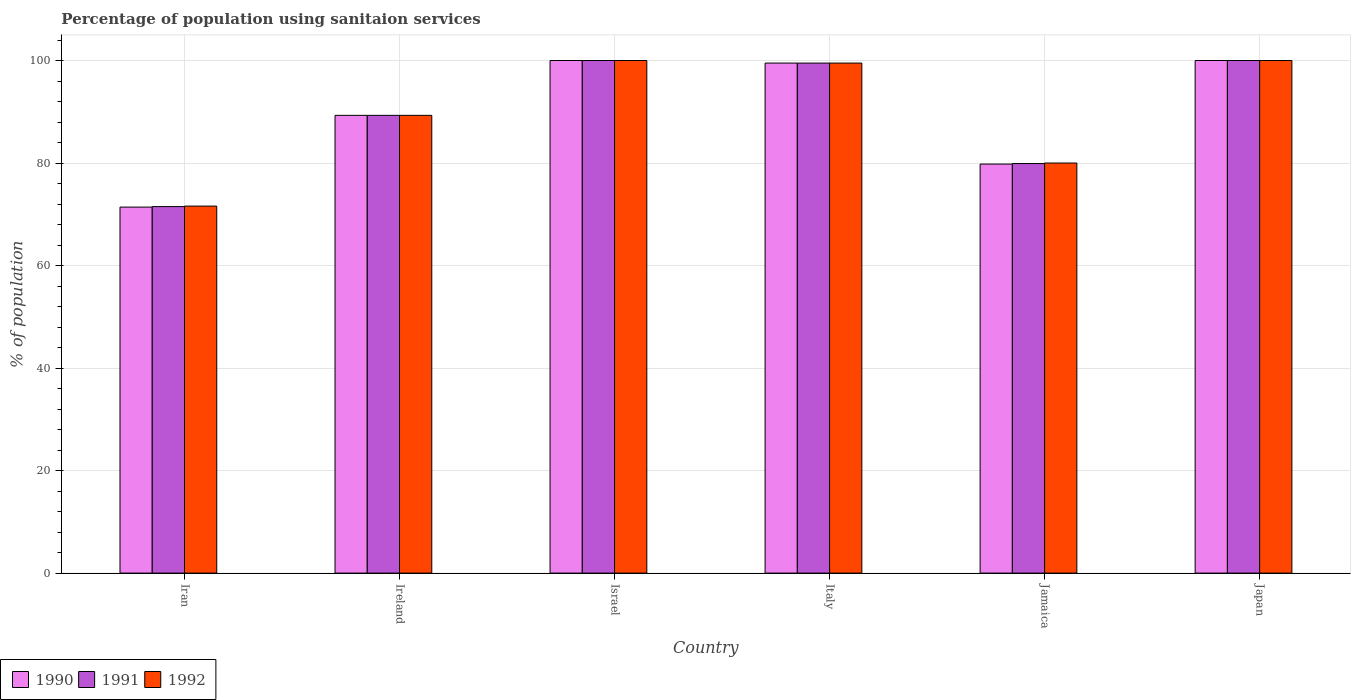How many different coloured bars are there?
Offer a terse response. 3. Are the number of bars per tick equal to the number of legend labels?
Offer a terse response. Yes. Are the number of bars on each tick of the X-axis equal?
Keep it short and to the point. Yes. How many bars are there on the 4th tick from the right?
Make the answer very short. 3. What is the percentage of population using sanitaion services in 1990 in Israel?
Make the answer very short. 100. Across all countries, what is the maximum percentage of population using sanitaion services in 1992?
Provide a short and direct response. 100. Across all countries, what is the minimum percentage of population using sanitaion services in 1991?
Give a very brief answer. 71.5. In which country was the percentage of population using sanitaion services in 1990 maximum?
Give a very brief answer. Israel. In which country was the percentage of population using sanitaion services in 1990 minimum?
Your answer should be very brief. Iran. What is the total percentage of population using sanitaion services in 1990 in the graph?
Provide a short and direct response. 540. What is the difference between the percentage of population using sanitaion services in 1991 in Iran and that in Israel?
Provide a succinct answer. -28.5. What is the difference between the percentage of population using sanitaion services in 1990 in Iran and the percentage of population using sanitaion services in 1991 in Japan?
Make the answer very short. -28.6. What is the average percentage of population using sanitaion services in 1992 per country?
Offer a very short reply. 90.07. What is the difference between the percentage of population using sanitaion services of/in 1991 and percentage of population using sanitaion services of/in 1990 in Ireland?
Your response must be concise. 0. In how many countries, is the percentage of population using sanitaion services in 1990 greater than 4 %?
Your answer should be compact. 6. What is the ratio of the percentage of population using sanitaion services in 1991 in Ireland to that in Italy?
Keep it short and to the point. 0.9. What is the difference between the highest and the lowest percentage of population using sanitaion services in 1990?
Ensure brevity in your answer.  28.6. In how many countries, is the percentage of population using sanitaion services in 1991 greater than the average percentage of population using sanitaion services in 1991 taken over all countries?
Provide a short and direct response. 3. What does the 1st bar from the left in Japan represents?
Make the answer very short. 1990. Is it the case that in every country, the sum of the percentage of population using sanitaion services in 1991 and percentage of population using sanitaion services in 1990 is greater than the percentage of population using sanitaion services in 1992?
Ensure brevity in your answer.  Yes. How many bars are there?
Your answer should be very brief. 18. Are all the bars in the graph horizontal?
Your answer should be very brief. No. How many countries are there in the graph?
Ensure brevity in your answer.  6. Does the graph contain any zero values?
Ensure brevity in your answer.  No. Does the graph contain grids?
Ensure brevity in your answer.  Yes. How are the legend labels stacked?
Ensure brevity in your answer.  Horizontal. What is the title of the graph?
Ensure brevity in your answer.  Percentage of population using sanitaion services. What is the label or title of the X-axis?
Offer a very short reply. Country. What is the label or title of the Y-axis?
Your answer should be very brief. % of population. What is the % of population in 1990 in Iran?
Give a very brief answer. 71.4. What is the % of population of 1991 in Iran?
Provide a short and direct response. 71.5. What is the % of population of 1992 in Iran?
Your response must be concise. 71.6. What is the % of population in 1990 in Ireland?
Your response must be concise. 89.3. What is the % of population of 1991 in Ireland?
Keep it short and to the point. 89.3. What is the % of population of 1992 in Ireland?
Make the answer very short. 89.3. What is the % of population of 1990 in Israel?
Your answer should be compact. 100. What is the % of population of 1991 in Israel?
Provide a short and direct response. 100. What is the % of population of 1990 in Italy?
Provide a short and direct response. 99.5. What is the % of population in 1991 in Italy?
Your answer should be very brief. 99.5. What is the % of population of 1992 in Italy?
Offer a very short reply. 99.5. What is the % of population in 1990 in Jamaica?
Your answer should be compact. 79.8. What is the % of population of 1991 in Jamaica?
Your response must be concise. 79.9. What is the % of population of 1992 in Japan?
Your answer should be very brief. 100. Across all countries, what is the maximum % of population in 1991?
Your answer should be very brief. 100. Across all countries, what is the maximum % of population of 1992?
Your answer should be very brief. 100. Across all countries, what is the minimum % of population in 1990?
Provide a succinct answer. 71.4. Across all countries, what is the minimum % of population in 1991?
Make the answer very short. 71.5. Across all countries, what is the minimum % of population in 1992?
Provide a short and direct response. 71.6. What is the total % of population in 1990 in the graph?
Keep it short and to the point. 540. What is the total % of population of 1991 in the graph?
Keep it short and to the point. 540.2. What is the total % of population of 1992 in the graph?
Provide a succinct answer. 540.4. What is the difference between the % of population in 1990 in Iran and that in Ireland?
Keep it short and to the point. -17.9. What is the difference between the % of population in 1991 in Iran and that in Ireland?
Keep it short and to the point. -17.8. What is the difference between the % of population of 1992 in Iran and that in Ireland?
Provide a short and direct response. -17.7. What is the difference between the % of population of 1990 in Iran and that in Israel?
Offer a terse response. -28.6. What is the difference between the % of population of 1991 in Iran and that in Israel?
Your answer should be compact. -28.5. What is the difference between the % of population in 1992 in Iran and that in Israel?
Provide a short and direct response. -28.4. What is the difference between the % of population in 1990 in Iran and that in Italy?
Provide a succinct answer. -28.1. What is the difference between the % of population of 1991 in Iran and that in Italy?
Your answer should be compact. -28. What is the difference between the % of population of 1992 in Iran and that in Italy?
Provide a short and direct response. -27.9. What is the difference between the % of population in 1992 in Iran and that in Jamaica?
Offer a terse response. -8.4. What is the difference between the % of population of 1990 in Iran and that in Japan?
Keep it short and to the point. -28.6. What is the difference between the % of population in 1991 in Iran and that in Japan?
Your answer should be very brief. -28.5. What is the difference between the % of population in 1992 in Iran and that in Japan?
Your answer should be compact. -28.4. What is the difference between the % of population of 1992 in Ireland and that in Israel?
Give a very brief answer. -10.7. What is the difference between the % of population of 1992 in Ireland and that in Jamaica?
Offer a terse response. 9.3. What is the difference between the % of population of 1990 in Ireland and that in Japan?
Provide a succinct answer. -10.7. What is the difference between the % of population of 1992 in Ireland and that in Japan?
Your answer should be compact. -10.7. What is the difference between the % of population in 1991 in Israel and that in Italy?
Your response must be concise. 0.5. What is the difference between the % of population in 1990 in Israel and that in Jamaica?
Provide a short and direct response. 20.2. What is the difference between the % of population in 1991 in Israel and that in Jamaica?
Offer a terse response. 20.1. What is the difference between the % of population of 1992 in Israel and that in Jamaica?
Give a very brief answer. 20. What is the difference between the % of population in 1990 in Israel and that in Japan?
Keep it short and to the point. 0. What is the difference between the % of population of 1990 in Italy and that in Jamaica?
Ensure brevity in your answer.  19.7. What is the difference between the % of population in 1991 in Italy and that in Jamaica?
Your answer should be compact. 19.6. What is the difference between the % of population in 1991 in Italy and that in Japan?
Your answer should be very brief. -0.5. What is the difference between the % of population of 1990 in Jamaica and that in Japan?
Your answer should be compact. -20.2. What is the difference between the % of population in 1991 in Jamaica and that in Japan?
Make the answer very short. -20.1. What is the difference between the % of population in 1992 in Jamaica and that in Japan?
Provide a short and direct response. -20. What is the difference between the % of population in 1990 in Iran and the % of population in 1991 in Ireland?
Offer a terse response. -17.9. What is the difference between the % of population of 1990 in Iran and the % of population of 1992 in Ireland?
Offer a very short reply. -17.9. What is the difference between the % of population of 1991 in Iran and the % of population of 1992 in Ireland?
Your answer should be compact. -17.8. What is the difference between the % of population in 1990 in Iran and the % of population in 1991 in Israel?
Offer a very short reply. -28.6. What is the difference between the % of population in 1990 in Iran and the % of population in 1992 in Israel?
Your answer should be compact. -28.6. What is the difference between the % of population of 1991 in Iran and the % of population of 1992 in Israel?
Provide a short and direct response. -28.5. What is the difference between the % of population of 1990 in Iran and the % of population of 1991 in Italy?
Your answer should be very brief. -28.1. What is the difference between the % of population in 1990 in Iran and the % of population in 1992 in Italy?
Offer a terse response. -28.1. What is the difference between the % of population in 1990 in Iran and the % of population in 1992 in Jamaica?
Your answer should be very brief. -8.6. What is the difference between the % of population in 1991 in Iran and the % of population in 1992 in Jamaica?
Give a very brief answer. -8.5. What is the difference between the % of population of 1990 in Iran and the % of population of 1991 in Japan?
Make the answer very short. -28.6. What is the difference between the % of population of 1990 in Iran and the % of population of 1992 in Japan?
Make the answer very short. -28.6. What is the difference between the % of population in 1991 in Iran and the % of population in 1992 in Japan?
Provide a succinct answer. -28.5. What is the difference between the % of population in 1990 in Ireland and the % of population in 1991 in Israel?
Offer a terse response. -10.7. What is the difference between the % of population of 1991 in Ireland and the % of population of 1992 in Israel?
Provide a short and direct response. -10.7. What is the difference between the % of population in 1990 in Ireland and the % of population in 1991 in Italy?
Offer a terse response. -10.2. What is the difference between the % of population of 1990 in Ireland and the % of population of 1992 in Italy?
Your answer should be very brief. -10.2. What is the difference between the % of population of 1990 in Ireland and the % of population of 1991 in Jamaica?
Ensure brevity in your answer.  9.4. What is the difference between the % of population of 1991 in Ireland and the % of population of 1992 in Jamaica?
Offer a terse response. 9.3. What is the difference between the % of population of 1990 in Ireland and the % of population of 1991 in Japan?
Your answer should be compact. -10.7. What is the difference between the % of population of 1990 in Ireland and the % of population of 1992 in Japan?
Your response must be concise. -10.7. What is the difference between the % of population in 1991 in Ireland and the % of population in 1992 in Japan?
Your response must be concise. -10.7. What is the difference between the % of population of 1991 in Israel and the % of population of 1992 in Italy?
Give a very brief answer. 0.5. What is the difference between the % of population in 1990 in Israel and the % of population in 1991 in Jamaica?
Make the answer very short. 20.1. What is the difference between the % of population of 1991 in Israel and the % of population of 1992 in Jamaica?
Offer a terse response. 20. What is the difference between the % of population of 1990 in Italy and the % of population of 1991 in Jamaica?
Your answer should be compact. 19.6. What is the difference between the % of population of 1990 in Italy and the % of population of 1992 in Jamaica?
Offer a terse response. 19.5. What is the difference between the % of population of 1991 in Italy and the % of population of 1992 in Jamaica?
Keep it short and to the point. 19.5. What is the difference between the % of population in 1990 in Italy and the % of population in 1992 in Japan?
Your answer should be compact. -0.5. What is the difference between the % of population of 1990 in Jamaica and the % of population of 1991 in Japan?
Your answer should be compact. -20.2. What is the difference between the % of population of 1990 in Jamaica and the % of population of 1992 in Japan?
Your response must be concise. -20.2. What is the difference between the % of population in 1991 in Jamaica and the % of population in 1992 in Japan?
Make the answer very short. -20.1. What is the average % of population of 1991 per country?
Your response must be concise. 90.03. What is the average % of population in 1992 per country?
Your answer should be compact. 90.07. What is the difference between the % of population of 1991 and % of population of 1992 in Iran?
Give a very brief answer. -0.1. What is the difference between the % of population in 1990 and % of population in 1991 in Israel?
Provide a short and direct response. 0. What is the difference between the % of population of 1991 and % of population of 1992 in Italy?
Provide a succinct answer. 0. What is the difference between the % of population in 1990 and % of population in 1991 in Jamaica?
Provide a short and direct response. -0.1. What is the difference between the % of population in 1990 and % of population in 1992 in Jamaica?
Ensure brevity in your answer.  -0.2. What is the difference between the % of population in 1991 and % of population in 1992 in Jamaica?
Provide a succinct answer. -0.1. What is the difference between the % of population in 1990 and % of population in 1991 in Japan?
Your answer should be very brief. 0. What is the difference between the % of population of 1990 and % of population of 1992 in Japan?
Provide a short and direct response. 0. What is the difference between the % of population of 1991 and % of population of 1992 in Japan?
Your answer should be compact. 0. What is the ratio of the % of population in 1990 in Iran to that in Ireland?
Provide a succinct answer. 0.8. What is the ratio of the % of population of 1991 in Iran to that in Ireland?
Make the answer very short. 0.8. What is the ratio of the % of population in 1992 in Iran to that in Ireland?
Your response must be concise. 0.8. What is the ratio of the % of population of 1990 in Iran to that in Israel?
Give a very brief answer. 0.71. What is the ratio of the % of population of 1991 in Iran to that in Israel?
Your response must be concise. 0.71. What is the ratio of the % of population of 1992 in Iran to that in Israel?
Your answer should be very brief. 0.72. What is the ratio of the % of population in 1990 in Iran to that in Italy?
Your answer should be very brief. 0.72. What is the ratio of the % of population of 1991 in Iran to that in Italy?
Keep it short and to the point. 0.72. What is the ratio of the % of population of 1992 in Iran to that in Italy?
Provide a short and direct response. 0.72. What is the ratio of the % of population in 1990 in Iran to that in Jamaica?
Give a very brief answer. 0.89. What is the ratio of the % of population of 1991 in Iran to that in Jamaica?
Ensure brevity in your answer.  0.89. What is the ratio of the % of population of 1992 in Iran to that in Jamaica?
Offer a terse response. 0.9. What is the ratio of the % of population in 1990 in Iran to that in Japan?
Offer a terse response. 0.71. What is the ratio of the % of population of 1991 in Iran to that in Japan?
Ensure brevity in your answer.  0.71. What is the ratio of the % of population of 1992 in Iran to that in Japan?
Your answer should be very brief. 0.72. What is the ratio of the % of population in 1990 in Ireland to that in Israel?
Provide a succinct answer. 0.89. What is the ratio of the % of population of 1991 in Ireland to that in Israel?
Offer a very short reply. 0.89. What is the ratio of the % of population of 1992 in Ireland to that in Israel?
Keep it short and to the point. 0.89. What is the ratio of the % of population of 1990 in Ireland to that in Italy?
Your answer should be compact. 0.9. What is the ratio of the % of population of 1991 in Ireland to that in Italy?
Provide a succinct answer. 0.9. What is the ratio of the % of population of 1992 in Ireland to that in Italy?
Offer a terse response. 0.9. What is the ratio of the % of population of 1990 in Ireland to that in Jamaica?
Provide a short and direct response. 1.12. What is the ratio of the % of population of 1991 in Ireland to that in Jamaica?
Ensure brevity in your answer.  1.12. What is the ratio of the % of population in 1992 in Ireland to that in Jamaica?
Offer a very short reply. 1.12. What is the ratio of the % of population in 1990 in Ireland to that in Japan?
Your response must be concise. 0.89. What is the ratio of the % of population of 1991 in Ireland to that in Japan?
Ensure brevity in your answer.  0.89. What is the ratio of the % of population in 1992 in Ireland to that in Japan?
Ensure brevity in your answer.  0.89. What is the ratio of the % of population in 1991 in Israel to that in Italy?
Provide a short and direct response. 1. What is the ratio of the % of population in 1992 in Israel to that in Italy?
Make the answer very short. 1. What is the ratio of the % of population in 1990 in Israel to that in Jamaica?
Your answer should be very brief. 1.25. What is the ratio of the % of population of 1991 in Israel to that in Jamaica?
Keep it short and to the point. 1.25. What is the ratio of the % of population in 1992 in Israel to that in Jamaica?
Your response must be concise. 1.25. What is the ratio of the % of population in 1990 in Israel to that in Japan?
Make the answer very short. 1. What is the ratio of the % of population of 1991 in Israel to that in Japan?
Provide a succinct answer. 1. What is the ratio of the % of population in 1992 in Israel to that in Japan?
Provide a succinct answer. 1. What is the ratio of the % of population in 1990 in Italy to that in Jamaica?
Your answer should be compact. 1.25. What is the ratio of the % of population in 1991 in Italy to that in Jamaica?
Provide a succinct answer. 1.25. What is the ratio of the % of population in 1992 in Italy to that in Jamaica?
Your response must be concise. 1.24. What is the ratio of the % of population in 1990 in Italy to that in Japan?
Give a very brief answer. 0.99. What is the ratio of the % of population in 1991 in Italy to that in Japan?
Give a very brief answer. 0.99. What is the ratio of the % of population in 1990 in Jamaica to that in Japan?
Offer a very short reply. 0.8. What is the ratio of the % of population of 1991 in Jamaica to that in Japan?
Offer a very short reply. 0.8. What is the ratio of the % of population of 1992 in Jamaica to that in Japan?
Offer a terse response. 0.8. What is the difference between the highest and the second highest % of population in 1992?
Your answer should be compact. 0. What is the difference between the highest and the lowest % of population in 1990?
Offer a very short reply. 28.6. What is the difference between the highest and the lowest % of population in 1992?
Your answer should be compact. 28.4. 